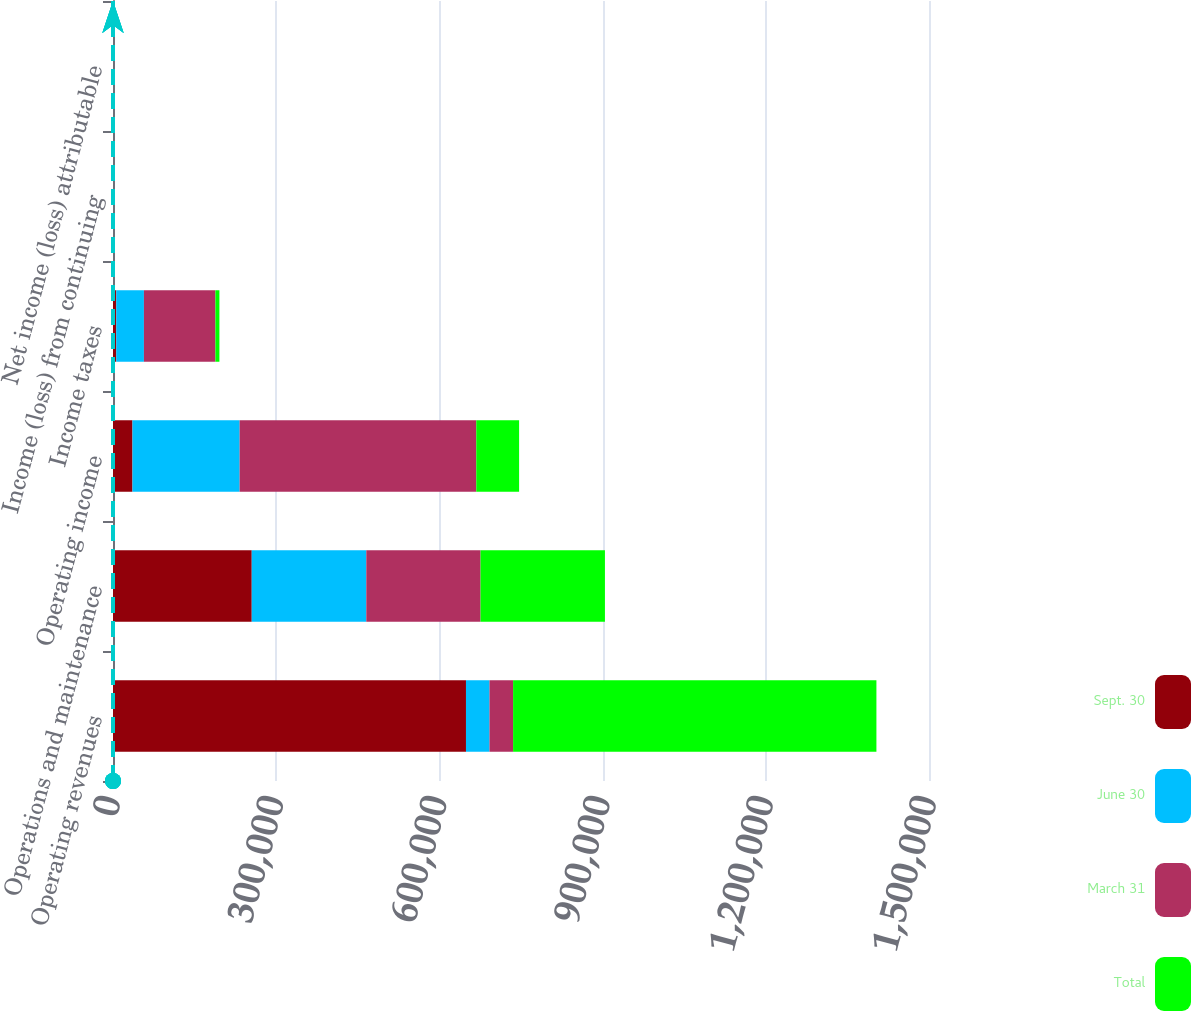Convert chart to OTSL. <chart><loc_0><loc_0><loc_500><loc_500><stacked_bar_chart><ecel><fcel>Operating revenues<fcel>Operations and maintenance<fcel>Operating income<fcel>Income taxes<fcel>Income (loss) from continuing<fcel>Net income (loss) attributable<nl><fcel>Sept. 30<fcel>648847<fcel>255029<fcel>35784<fcel>6005<fcel>0.15<fcel>0.14<nl><fcel>June 30<fcel>43301<fcel>210590<fcel>196992<fcel>50818<fcel>0.79<fcel>0.8<nl><fcel>March 31<fcel>43301<fcel>210035<fcel>435017<fcel>131416<fcel>2.25<fcel>2.34<nl><fcel>Total<fcel>667892<fcel>228632<fcel>78715<fcel>7375<fcel>0.11<fcel>0.12<nl></chart> 